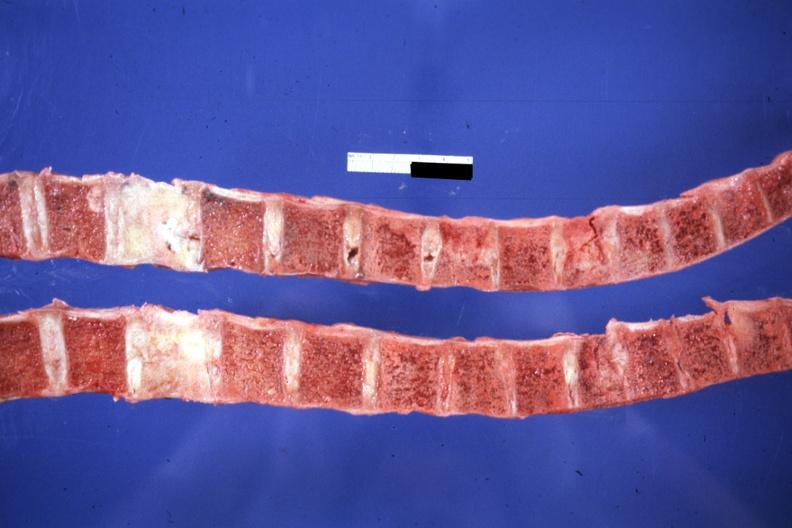what does this image show?
Answer the question using a single word or phrase. Saggital section typical do not know history but probably breast lesion 